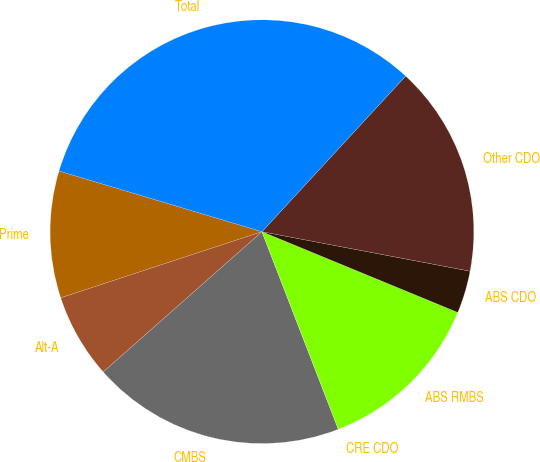<chart> <loc_0><loc_0><loc_500><loc_500><pie_chart><fcel>Prime<fcel>Alt-A<fcel>CMBS<fcel>CRE CDO<fcel>ABS RMBS<fcel>ABS CDO<fcel>Other CDO<fcel>Total<nl><fcel>9.68%<fcel>6.46%<fcel>19.35%<fcel>0.01%<fcel>12.9%<fcel>3.24%<fcel>16.12%<fcel>32.24%<nl></chart> 